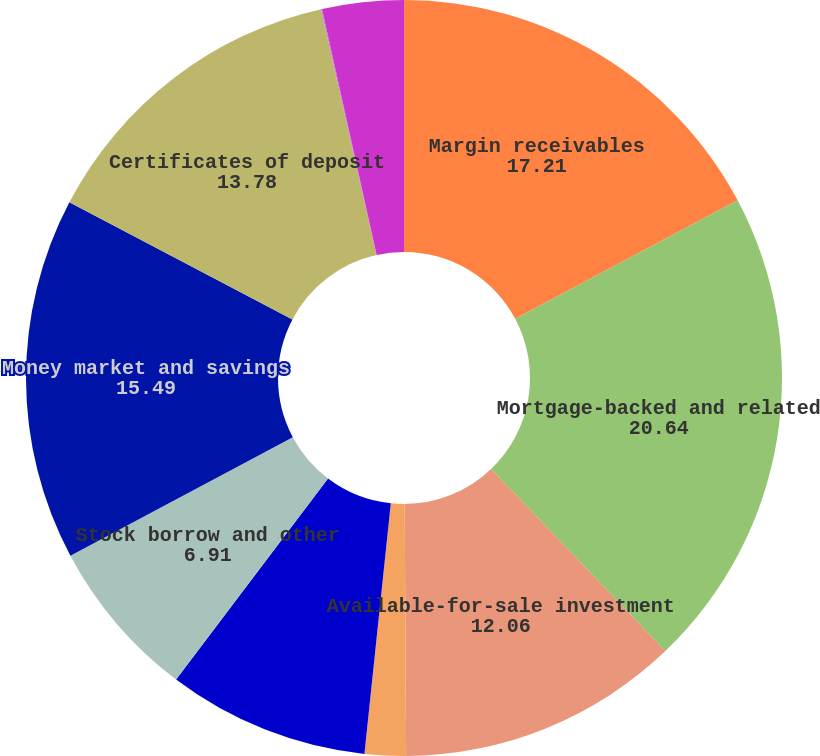Convert chart. <chart><loc_0><loc_0><loc_500><loc_500><pie_chart><fcel>Margin receivables<fcel>Mortgage-backed and related<fcel>Available-for-sale investment<fcel>Trading securities<fcel>Cash and cash equivalents (2)<fcel>Stock borrow and other<fcel>Money market and savings<fcel>Certificates of deposit<fcel>Checking accounts<fcel>Brokered certificates of<nl><fcel>17.21%<fcel>20.64%<fcel>12.06%<fcel>1.76%<fcel>8.63%<fcel>6.91%<fcel>15.49%<fcel>13.78%<fcel>0.04%<fcel>3.48%<nl></chart> 